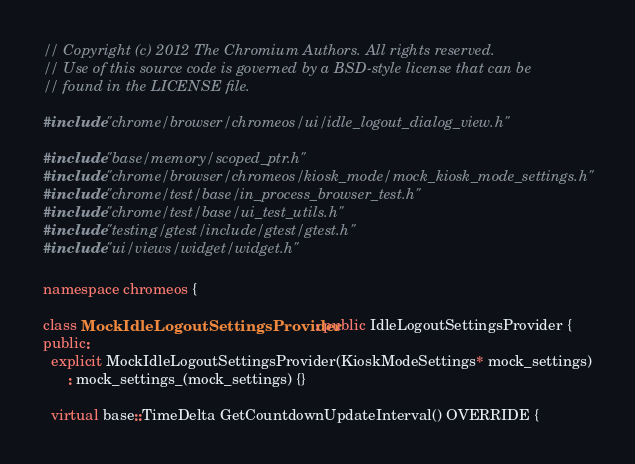Convert code to text. <code><loc_0><loc_0><loc_500><loc_500><_C++_>// Copyright (c) 2012 The Chromium Authors. All rights reserved.
// Use of this source code is governed by a BSD-style license that can be
// found in the LICENSE file.

#include "chrome/browser/chromeos/ui/idle_logout_dialog_view.h"

#include "base/memory/scoped_ptr.h"
#include "chrome/browser/chromeos/kiosk_mode/mock_kiosk_mode_settings.h"
#include "chrome/test/base/in_process_browser_test.h"
#include "chrome/test/base/ui_test_utils.h"
#include "testing/gtest/include/gtest/gtest.h"
#include "ui/views/widget/widget.h"

namespace chromeos {

class MockIdleLogoutSettingsProvider : public IdleLogoutSettingsProvider {
public:
  explicit MockIdleLogoutSettingsProvider(KioskModeSettings* mock_settings)
      : mock_settings_(mock_settings) {}

  virtual base::TimeDelta GetCountdownUpdateInterval() OVERRIDE {</code> 